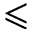<formula> <loc_0><loc_0><loc_500><loc_500>\leqslant</formula> 